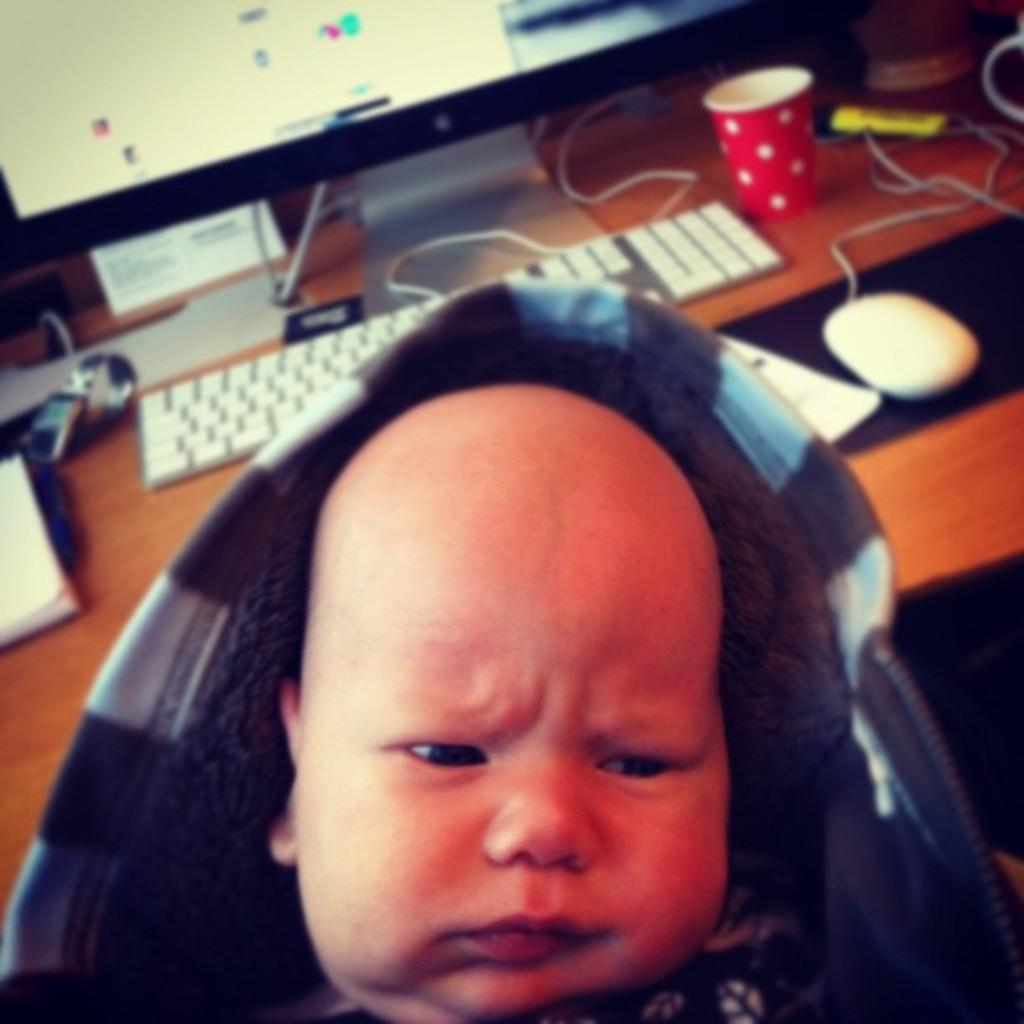Who is in the picture? There is a boy in the picture. What is the boy wearing? The boy is wearing a hoodie. What can be seen on the table in the image? A computer screen, a keyboard, a mouse, a glass, a wire, a book, paper, and other objects are on the table. What type of prose is the boy reading in the image? There is no book or any reading material visible in the image, so it is not possible to determine what type of prose the boy might be reading. 